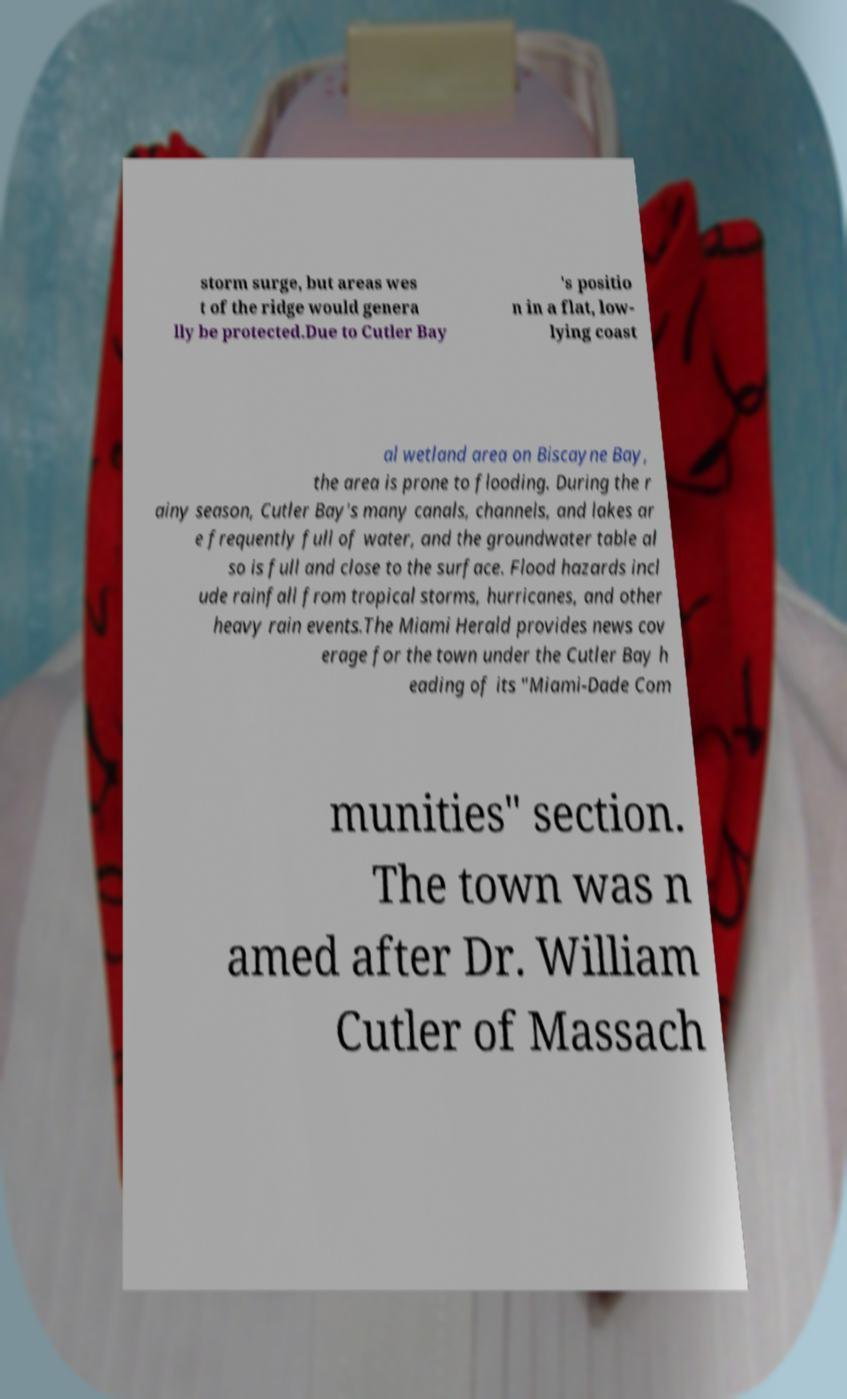Can you read and provide the text displayed in the image?This photo seems to have some interesting text. Can you extract and type it out for me? storm surge, but areas wes t of the ridge would genera lly be protected.Due to Cutler Bay 's positio n in a flat, low- lying coast al wetland area on Biscayne Bay, the area is prone to flooding. During the r ainy season, Cutler Bay's many canals, channels, and lakes ar e frequently full of water, and the groundwater table al so is full and close to the surface. Flood hazards incl ude rainfall from tropical storms, hurricanes, and other heavy rain events.The Miami Herald provides news cov erage for the town under the Cutler Bay h eading of its "Miami-Dade Com munities" section. The town was n amed after Dr. William Cutler of Massach 